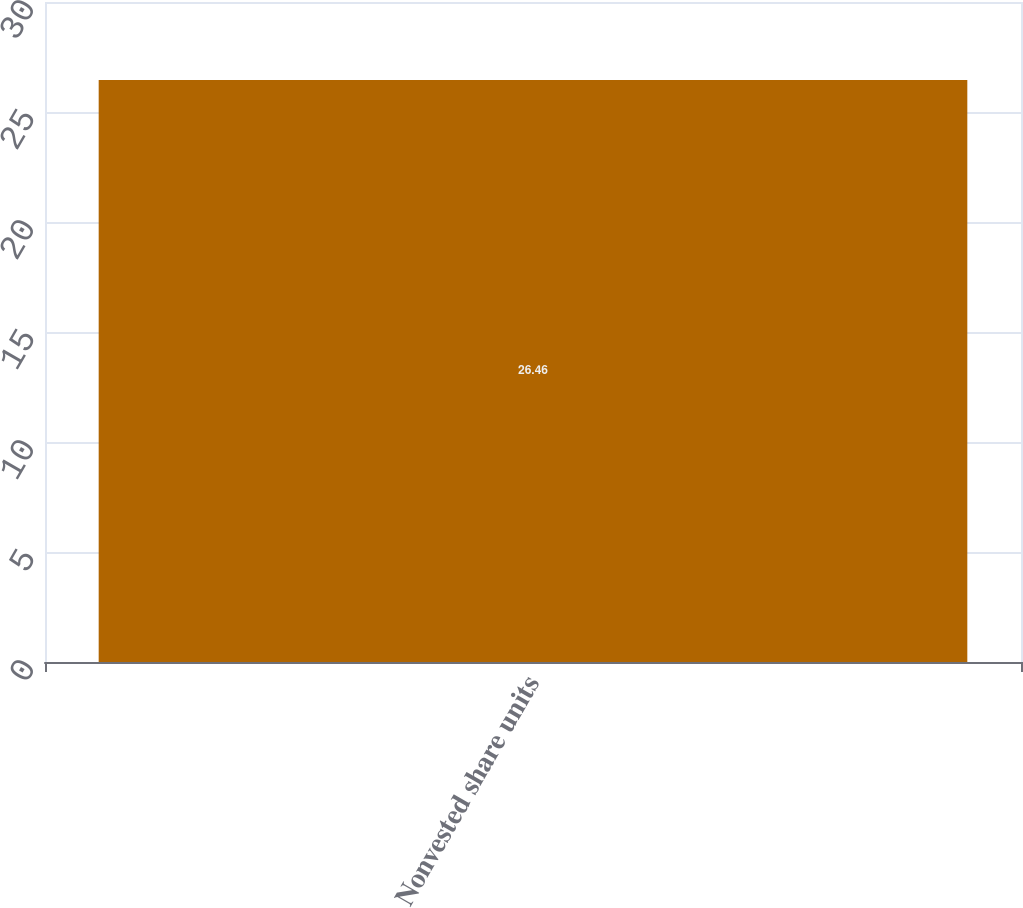<chart> <loc_0><loc_0><loc_500><loc_500><bar_chart><fcel>Nonvested share units<nl><fcel>26.46<nl></chart> 